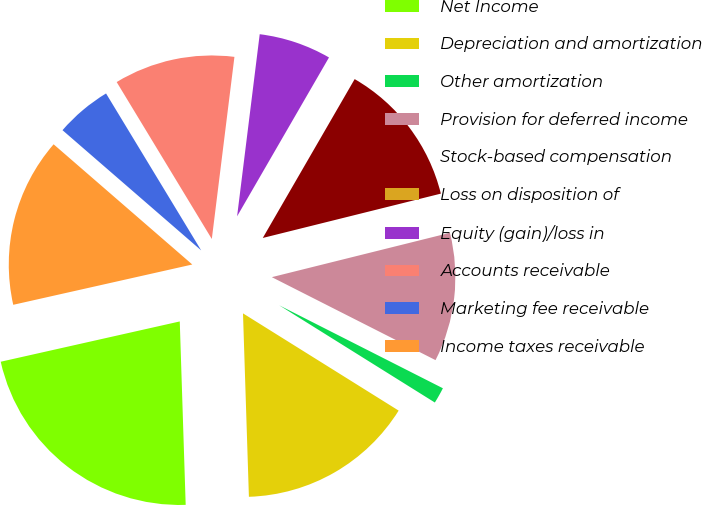<chart> <loc_0><loc_0><loc_500><loc_500><pie_chart><fcel>Net Income<fcel>Depreciation and amortization<fcel>Other amortization<fcel>Provision for deferred income<fcel>Stock-based compensation<fcel>Loss on disposition of<fcel>Equity (gain)/loss in<fcel>Accounts receivable<fcel>Marketing fee receivable<fcel>Income taxes receivable<nl><fcel>21.99%<fcel>15.6%<fcel>1.42%<fcel>11.35%<fcel>12.77%<fcel>0.0%<fcel>6.38%<fcel>10.64%<fcel>4.96%<fcel>14.89%<nl></chart> 